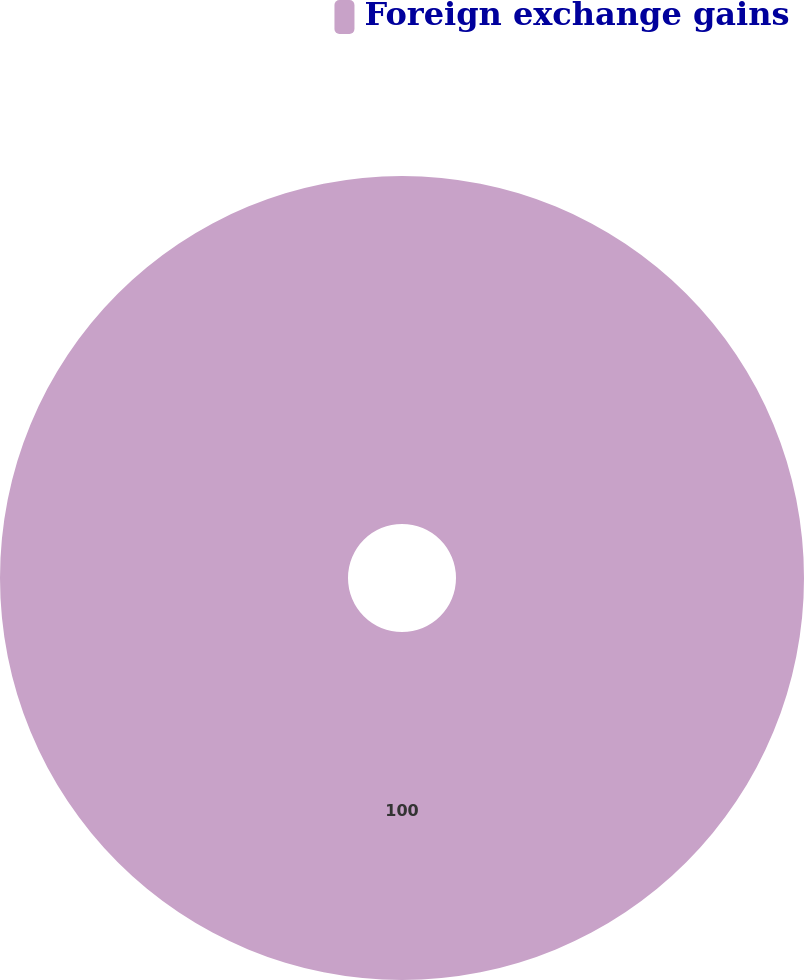<chart> <loc_0><loc_0><loc_500><loc_500><pie_chart><fcel>Foreign exchange gains<nl><fcel>100.0%<nl></chart> 